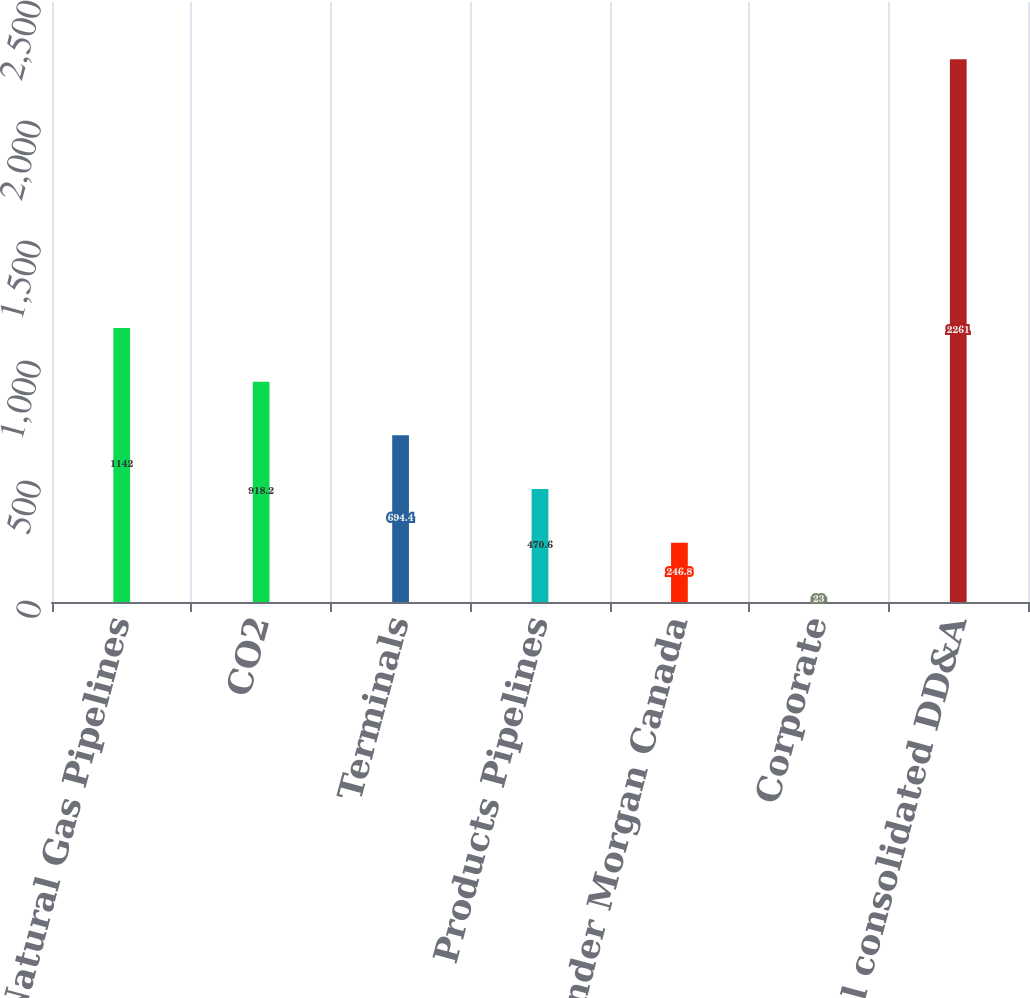Convert chart to OTSL. <chart><loc_0><loc_0><loc_500><loc_500><bar_chart><fcel>Natural Gas Pipelines<fcel>CO2<fcel>Terminals<fcel>Products Pipelines<fcel>Kinder Morgan Canada<fcel>Corporate<fcel>Total consolidated DD&A<nl><fcel>1142<fcel>918.2<fcel>694.4<fcel>470.6<fcel>246.8<fcel>23<fcel>2261<nl></chart> 